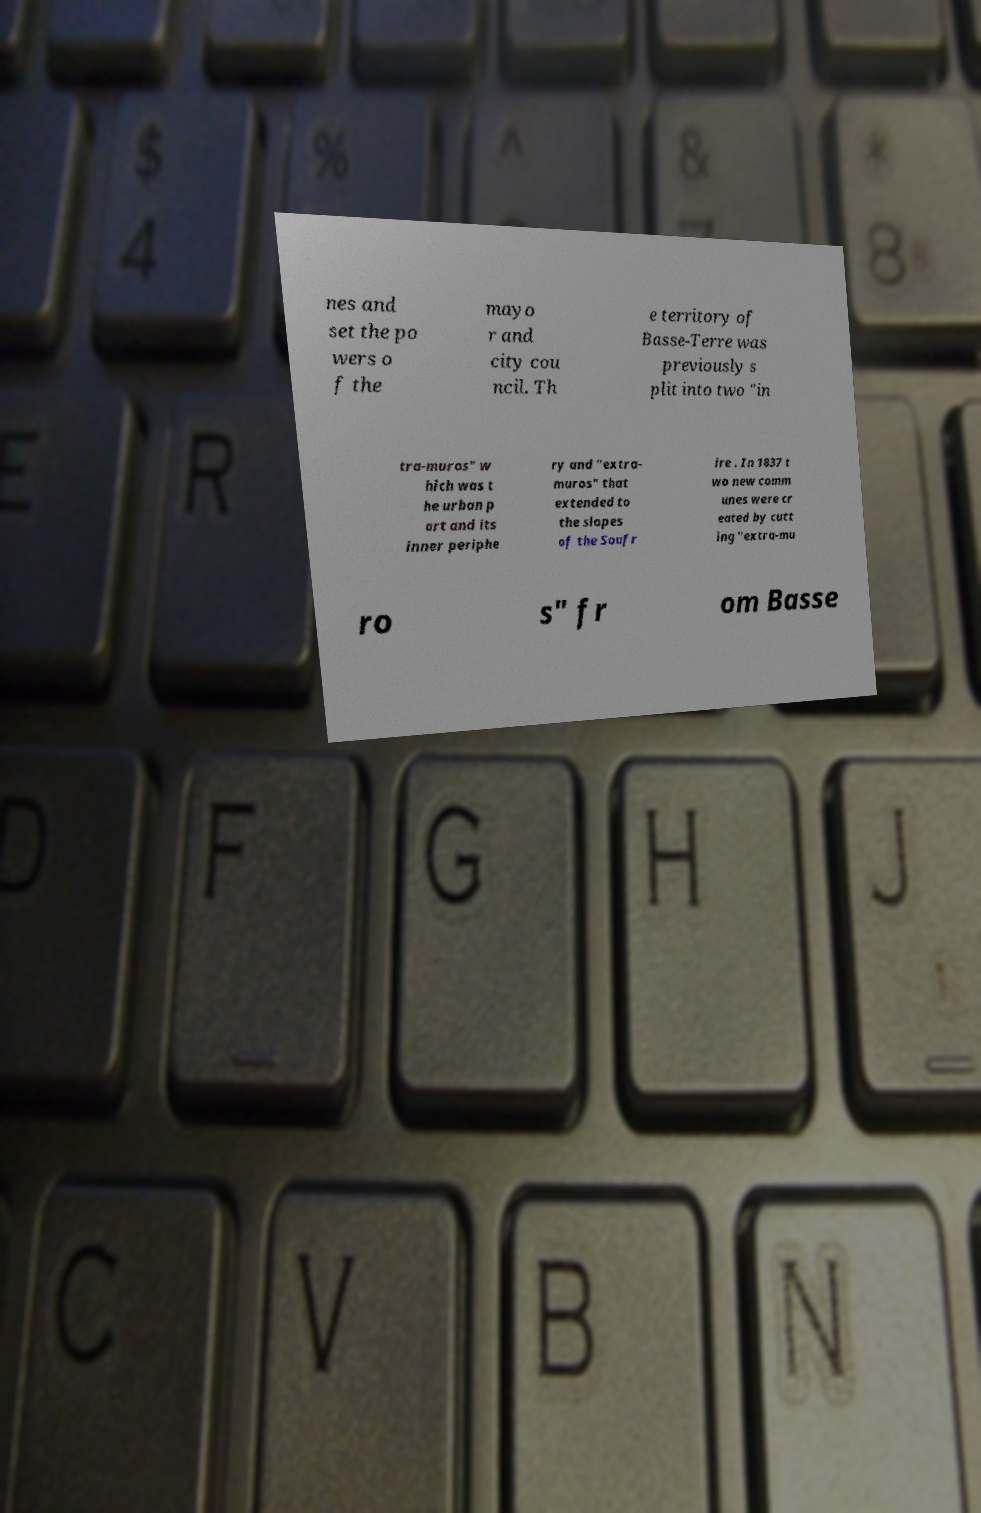Could you extract and type out the text from this image? nes and set the po wers o f the mayo r and city cou ncil. Th e territory of Basse-Terre was previously s plit into two "in tra-muros" w hich was t he urban p art and its inner periphe ry and "extra- muros" that extended to the slopes of the Soufr ire . In 1837 t wo new comm unes were cr eated by cutt ing "extra-mu ro s" fr om Basse 